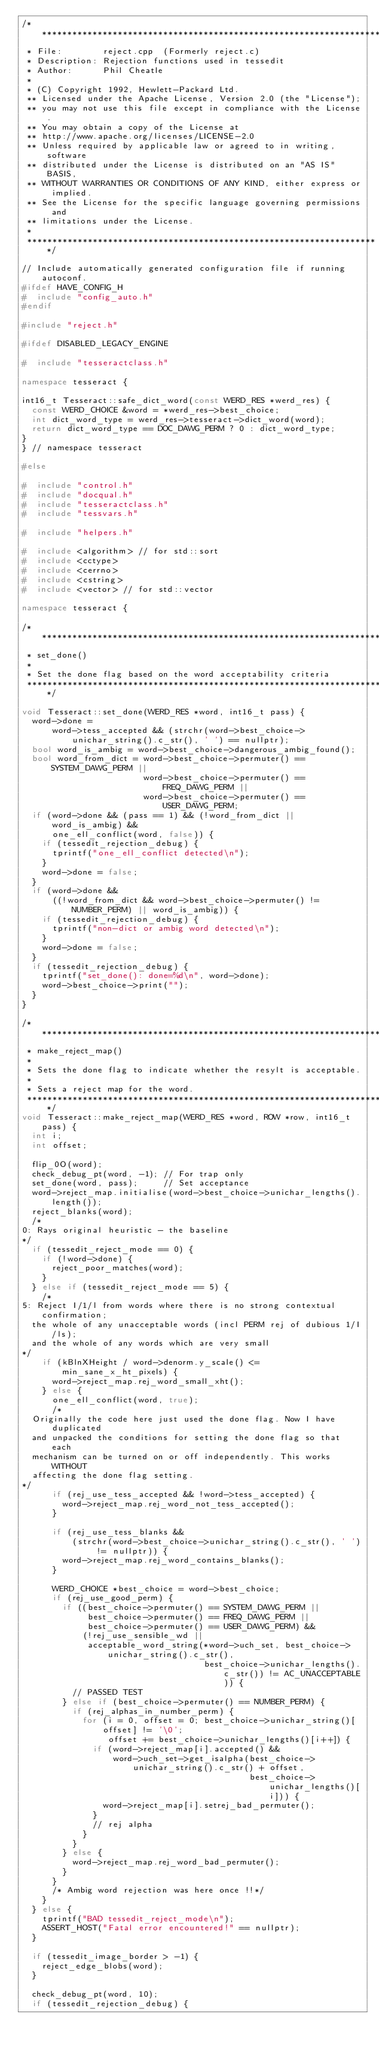Convert code to text. <code><loc_0><loc_0><loc_500><loc_500><_C++_>/**********************************************************************
 * File:        reject.cpp  (Formerly reject.c)
 * Description: Rejection functions used in tessedit
 * Author:      Phil Cheatle
 *
 * (C) Copyright 1992, Hewlett-Packard Ltd.
 ** Licensed under the Apache License, Version 2.0 (the "License");
 ** you may not use this file except in compliance with the License.
 ** You may obtain a copy of the License at
 ** http://www.apache.org/licenses/LICENSE-2.0
 ** Unless required by applicable law or agreed to in writing, software
 ** distributed under the License is distributed on an "AS IS" BASIS,
 ** WITHOUT WARRANTIES OR CONDITIONS OF ANY KIND, either express or implied.
 ** See the License for the specific language governing permissions and
 ** limitations under the License.
 *
 **********************************************************************/

// Include automatically generated configuration file if running autoconf.
#ifdef HAVE_CONFIG_H
#  include "config_auto.h"
#endif

#include "reject.h"

#ifdef DISABLED_LEGACY_ENGINE

#  include "tesseractclass.h"

namespace tesseract {

int16_t Tesseract::safe_dict_word(const WERD_RES *werd_res) {
  const WERD_CHOICE &word = *werd_res->best_choice;
  int dict_word_type = werd_res->tesseract->dict_word(word);
  return dict_word_type == DOC_DAWG_PERM ? 0 : dict_word_type;
}
} // namespace tesseract

#else

#  include "control.h"
#  include "docqual.h"
#  include "tesseractclass.h"
#  include "tessvars.h"

#  include "helpers.h"

#  include <algorithm> // for std::sort
#  include <cctype>
#  include <cerrno>
#  include <cstring>
#  include <vector> // for std::vector

namespace tesseract {

/*************************************************************************
 * set_done()
 *
 * Set the done flag based on the word acceptability criteria
 *************************************************************************/

void Tesseract::set_done(WERD_RES *word, int16_t pass) {
  word->done =
      word->tess_accepted && (strchr(word->best_choice->unichar_string().c_str(), ' ') == nullptr);
  bool word_is_ambig = word->best_choice->dangerous_ambig_found();
  bool word_from_dict = word->best_choice->permuter() == SYSTEM_DAWG_PERM ||
                        word->best_choice->permuter() == FREQ_DAWG_PERM ||
                        word->best_choice->permuter() == USER_DAWG_PERM;
  if (word->done && (pass == 1) && (!word_from_dict || word_is_ambig) &&
      one_ell_conflict(word, false)) {
    if (tessedit_rejection_debug) {
      tprintf("one_ell_conflict detected\n");
    }
    word->done = false;
  }
  if (word->done &&
      ((!word_from_dict && word->best_choice->permuter() != NUMBER_PERM) || word_is_ambig)) {
    if (tessedit_rejection_debug) {
      tprintf("non-dict or ambig word detected\n");
    }
    word->done = false;
  }
  if (tessedit_rejection_debug) {
    tprintf("set_done(): done=%d\n", word->done);
    word->best_choice->print("");
  }
}

/*************************************************************************
 * make_reject_map()
 *
 * Sets the done flag to indicate whether the resylt is acceptable.
 *
 * Sets a reject map for the word.
 *************************************************************************/
void Tesseract::make_reject_map(WERD_RES *word, ROW *row, int16_t pass) {
  int i;
  int offset;

  flip_0O(word);
  check_debug_pt(word, -1); // For trap only
  set_done(word, pass);     // Set acceptance
  word->reject_map.initialise(word->best_choice->unichar_lengths().length());
  reject_blanks(word);
  /*
0: Rays original heuristic - the baseline
*/
  if (tessedit_reject_mode == 0) {
    if (!word->done) {
      reject_poor_matches(word);
    }
  } else if (tessedit_reject_mode == 5) {
    /*
5: Reject I/1/l from words where there is no strong contextual confirmation;
  the whole of any unacceptable words (incl PERM rej of dubious 1/I/ls);
  and the whole of any words which are very small
*/
    if (kBlnXHeight / word->denorm.y_scale() <= min_sane_x_ht_pixels) {
      word->reject_map.rej_word_small_xht();
    } else {
      one_ell_conflict(word, true);
      /*
  Originally the code here just used the done flag. Now I have duplicated
  and unpacked the conditions for setting the done flag so that each
  mechanism can be turned on or off independently. This works WITHOUT
  affecting the done flag setting.
*/
      if (rej_use_tess_accepted && !word->tess_accepted) {
        word->reject_map.rej_word_not_tess_accepted();
      }

      if (rej_use_tess_blanks &&
          (strchr(word->best_choice->unichar_string().c_str(), ' ') != nullptr)) {
        word->reject_map.rej_word_contains_blanks();
      }

      WERD_CHOICE *best_choice = word->best_choice;
      if (rej_use_good_perm) {
        if ((best_choice->permuter() == SYSTEM_DAWG_PERM ||
             best_choice->permuter() == FREQ_DAWG_PERM ||
             best_choice->permuter() == USER_DAWG_PERM) &&
            (!rej_use_sensible_wd ||
             acceptable_word_string(*word->uch_set, best_choice->unichar_string().c_str(),
                                    best_choice->unichar_lengths().c_str()) != AC_UNACCEPTABLE)) {
          // PASSED TEST
        } else if (best_choice->permuter() == NUMBER_PERM) {
          if (rej_alphas_in_number_perm) {
            for (i = 0, offset = 0; best_choice->unichar_string()[offset] != '\0';
                 offset += best_choice->unichar_lengths()[i++]) {
              if (word->reject_map[i].accepted() &&
                  word->uch_set->get_isalpha(best_choice->unichar_string().c_str() + offset,
                                             best_choice->unichar_lengths()[i])) {
                word->reject_map[i].setrej_bad_permuter();
              }
              // rej alpha
            }
          }
        } else {
          word->reject_map.rej_word_bad_permuter();
        }
      }
      /* Ambig word rejection was here once !!*/
    }
  } else {
    tprintf("BAD tessedit_reject_mode\n");
    ASSERT_HOST("Fatal error encountered!" == nullptr);
  }

  if (tessedit_image_border > -1) {
    reject_edge_blobs(word);
  }

  check_debug_pt(word, 10);
  if (tessedit_rejection_debug) {</code> 